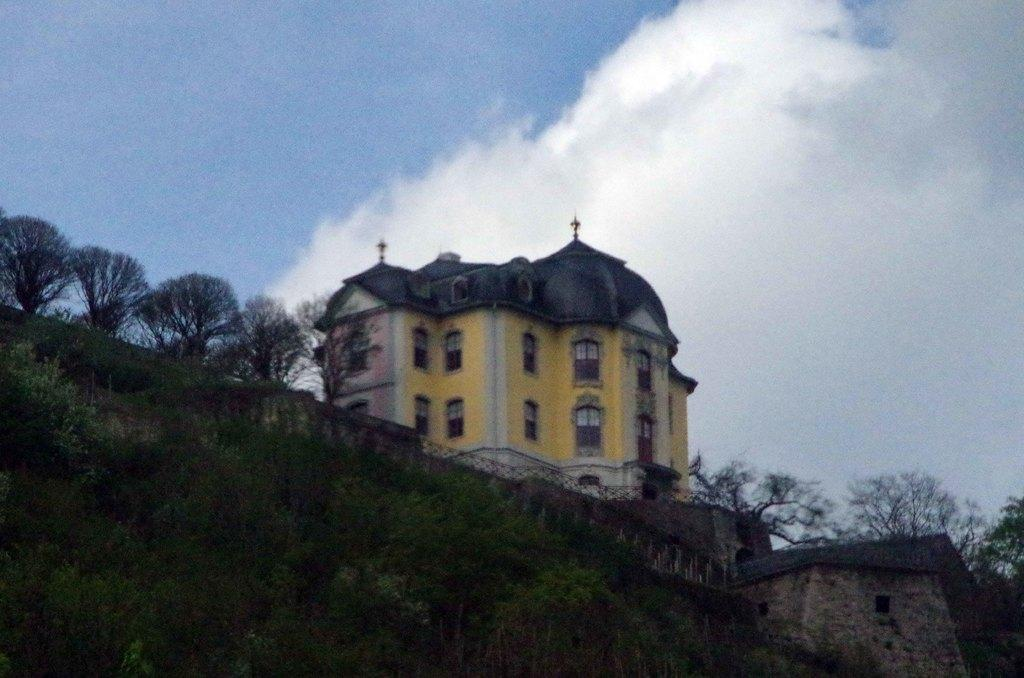What is the main structure in the center of the image? There is a building on a hill in the center of the image. What can be seen at the bottom of the image? Trees are visible at the bottom of the image. What is visible in the background of the image? There are trees and the sky visible in the background of the image. What can be observed in the sky in the background of the image? Clouds are present in the background of the image. Where is the toothbrush located in the image? There is no toothbrush present in the image. What type of pest can be seen crawling on the building in the image? There are no pests visible in the image; it features a building on a hill, trees, and a sky with clouds. 